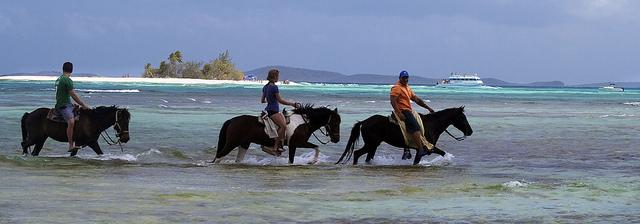What is the terrain with trees on it? Please explain your reasoning. private island. It is an island because it has water all around it. 